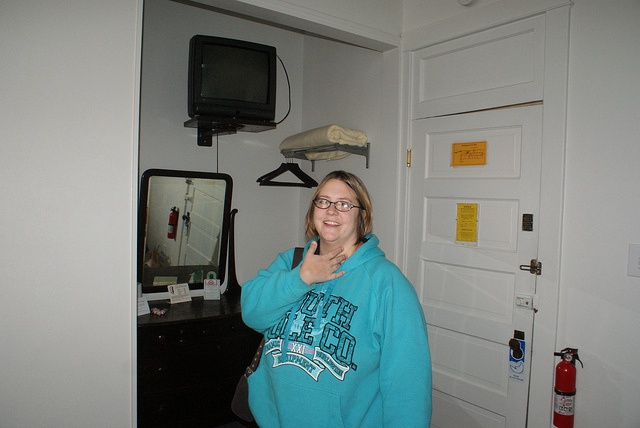Describe the objects in this image and their specific colors. I can see people in gray, teal, and black tones, tv in gray and black tones, and handbag in gray, black, teal, and maroon tones in this image. 